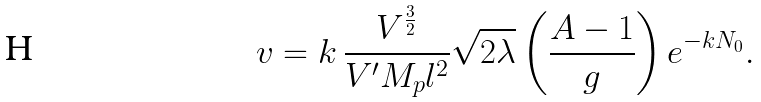<formula> <loc_0><loc_0><loc_500><loc_500>v = k \, \frac { V ^ { \frac { 3 } { 2 } } } { V ^ { \prime } M _ { p } l ^ { 2 } } \sqrt { 2 \lambda } \left ( \frac { A - 1 } { g } \right ) e ^ { - k N _ { 0 } } .</formula> 